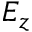Convert formula to latex. <formula><loc_0><loc_0><loc_500><loc_500>E _ { z }</formula> 